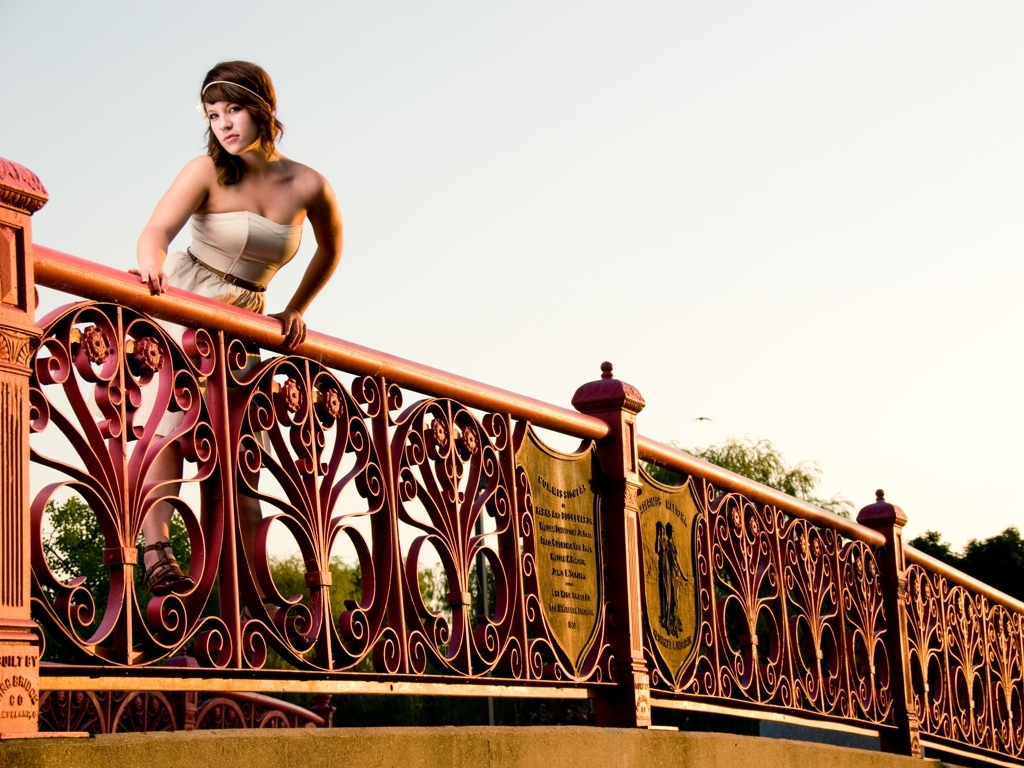Can you describe the style or historical period the bridge's railing design might represent? The railing design features ornamental scrollwork and symmetrical patterns typical of Victorian-era wrought ironwork. This suggests a historical influence, evoking a sense of elegance and attention to aesthetic details that were prevalent during the late 19th century. 